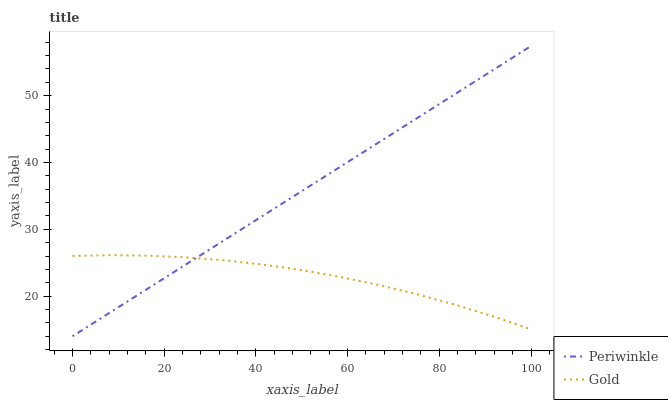Does Gold have the minimum area under the curve?
Answer yes or no. Yes. Does Periwinkle have the maximum area under the curve?
Answer yes or no. Yes. Does Gold have the maximum area under the curve?
Answer yes or no. No. Is Periwinkle the smoothest?
Answer yes or no. Yes. Is Gold the roughest?
Answer yes or no. Yes. Is Gold the smoothest?
Answer yes or no. No. Does Periwinkle have the lowest value?
Answer yes or no. Yes. Does Gold have the lowest value?
Answer yes or no. No. Does Periwinkle have the highest value?
Answer yes or no. Yes. Does Gold have the highest value?
Answer yes or no. No. Does Periwinkle intersect Gold?
Answer yes or no. Yes. Is Periwinkle less than Gold?
Answer yes or no. No. Is Periwinkle greater than Gold?
Answer yes or no. No. 